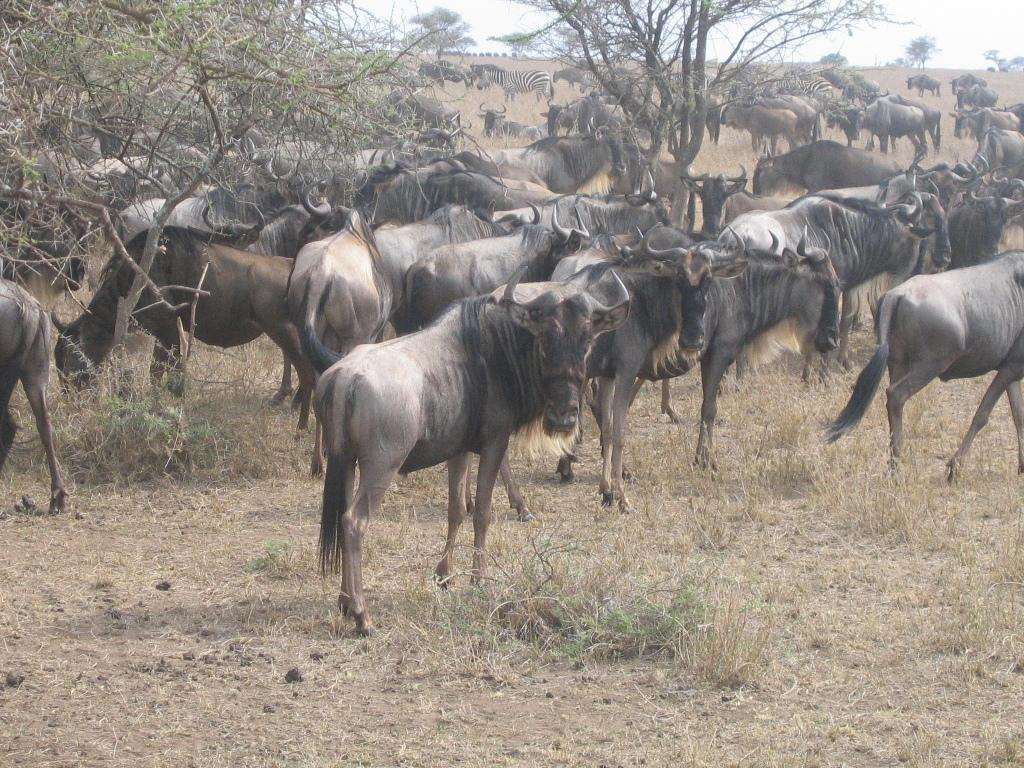What is the main subject of the image? The main subject of the image is many animals. What are the animals doing in the image? The animals are standing and grazing grass. What type of terrain is visible in the image? There is dry land with grass in the image. What can be seen in the front of the image? There are dry trees in the front of the image. What is visible above the animals and trees? The sky is visible in the image. How do the chickens express their love for each other in the image? There are no chickens present in the image, so it is not possible to determine how they might express love. 